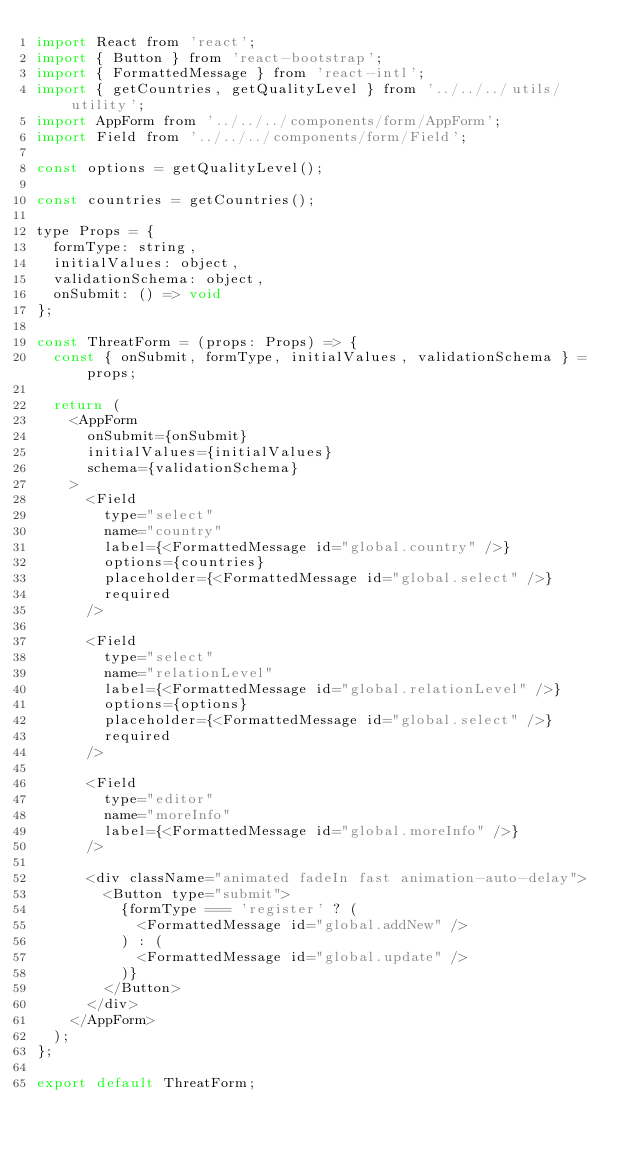<code> <loc_0><loc_0><loc_500><loc_500><_JavaScript_>import React from 'react';
import { Button } from 'react-bootstrap';
import { FormattedMessage } from 'react-intl';
import { getCountries, getQualityLevel } from '../../../utils/utility';
import AppForm from '../../../components/form/AppForm';
import Field from '../../../components/form/Field';

const options = getQualityLevel();

const countries = getCountries();

type Props = {
  formType: string,
  initialValues: object,
  validationSchema: object,
  onSubmit: () => void
};

const ThreatForm = (props: Props) => {
  const { onSubmit, formType, initialValues, validationSchema } = props;

  return (
    <AppForm
      onSubmit={onSubmit}
      initialValues={initialValues}
      schema={validationSchema}
    >
      <Field
        type="select"
        name="country"
        label={<FormattedMessage id="global.country" />}
        options={countries}
        placeholder={<FormattedMessage id="global.select" />}
        required
      />

      <Field
        type="select"
        name="relationLevel"
        label={<FormattedMessage id="global.relationLevel" />}
        options={options}
        placeholder={<FormattedMessage id="global.select" />}
        required
      />

      <Field
        type="editor"
        name="moreInfo"
        label={<FormattedMessage id="global.moreInfo" />}
      />

      <div className="animated fadeIn fast animation-auto-delay">
        <Button type="submit">
          {formType === 'register' ? (
            <FormattedMessage id="global.addNew" />
          ) : (
            <FormattedMessage id="global.update" />
          )}
        </Button>
      </div>
    </AppForm>
  );
};

export default ThreatForm;
</code> 